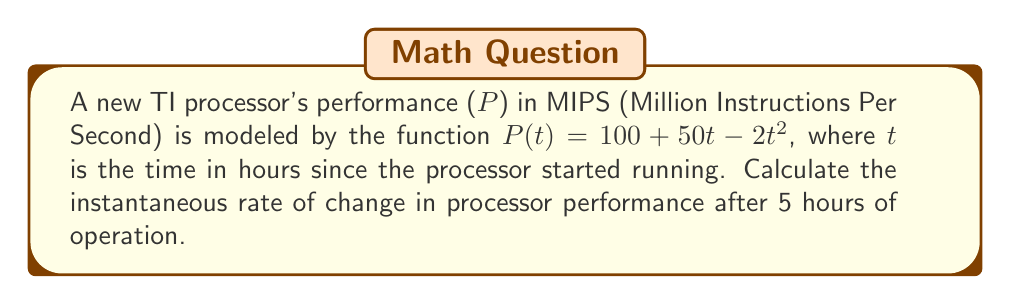Solve this math problem. To find the instantaneous rate of change in processor performance after 5 hours, we need to calculate the derivative of P(t) and evaluate it at t = 5.

Step 1: Calculate the derivative of P(t)
$$\frac{d}{dt}P(t) = \frac{d}{dt}(100 + 50t - 2t^2)$$
$$P'(t) = 50 - 4t$$

Step 2: Evaluate P'(t) at t = 5
$$P'(5) = 50 - 4(5)$$
$$P'(5) = 50 - 20$$
$$P'(5) = 30$$

The instantaneous rate of change is 30 MIPS per hour after 5 hours of operation.

Note: The negative value indicates that the processor's performance is increasing at a decreasing rate, which is consistent with the quadratic term in the original function.
Answer: 30 MIPS/hour 